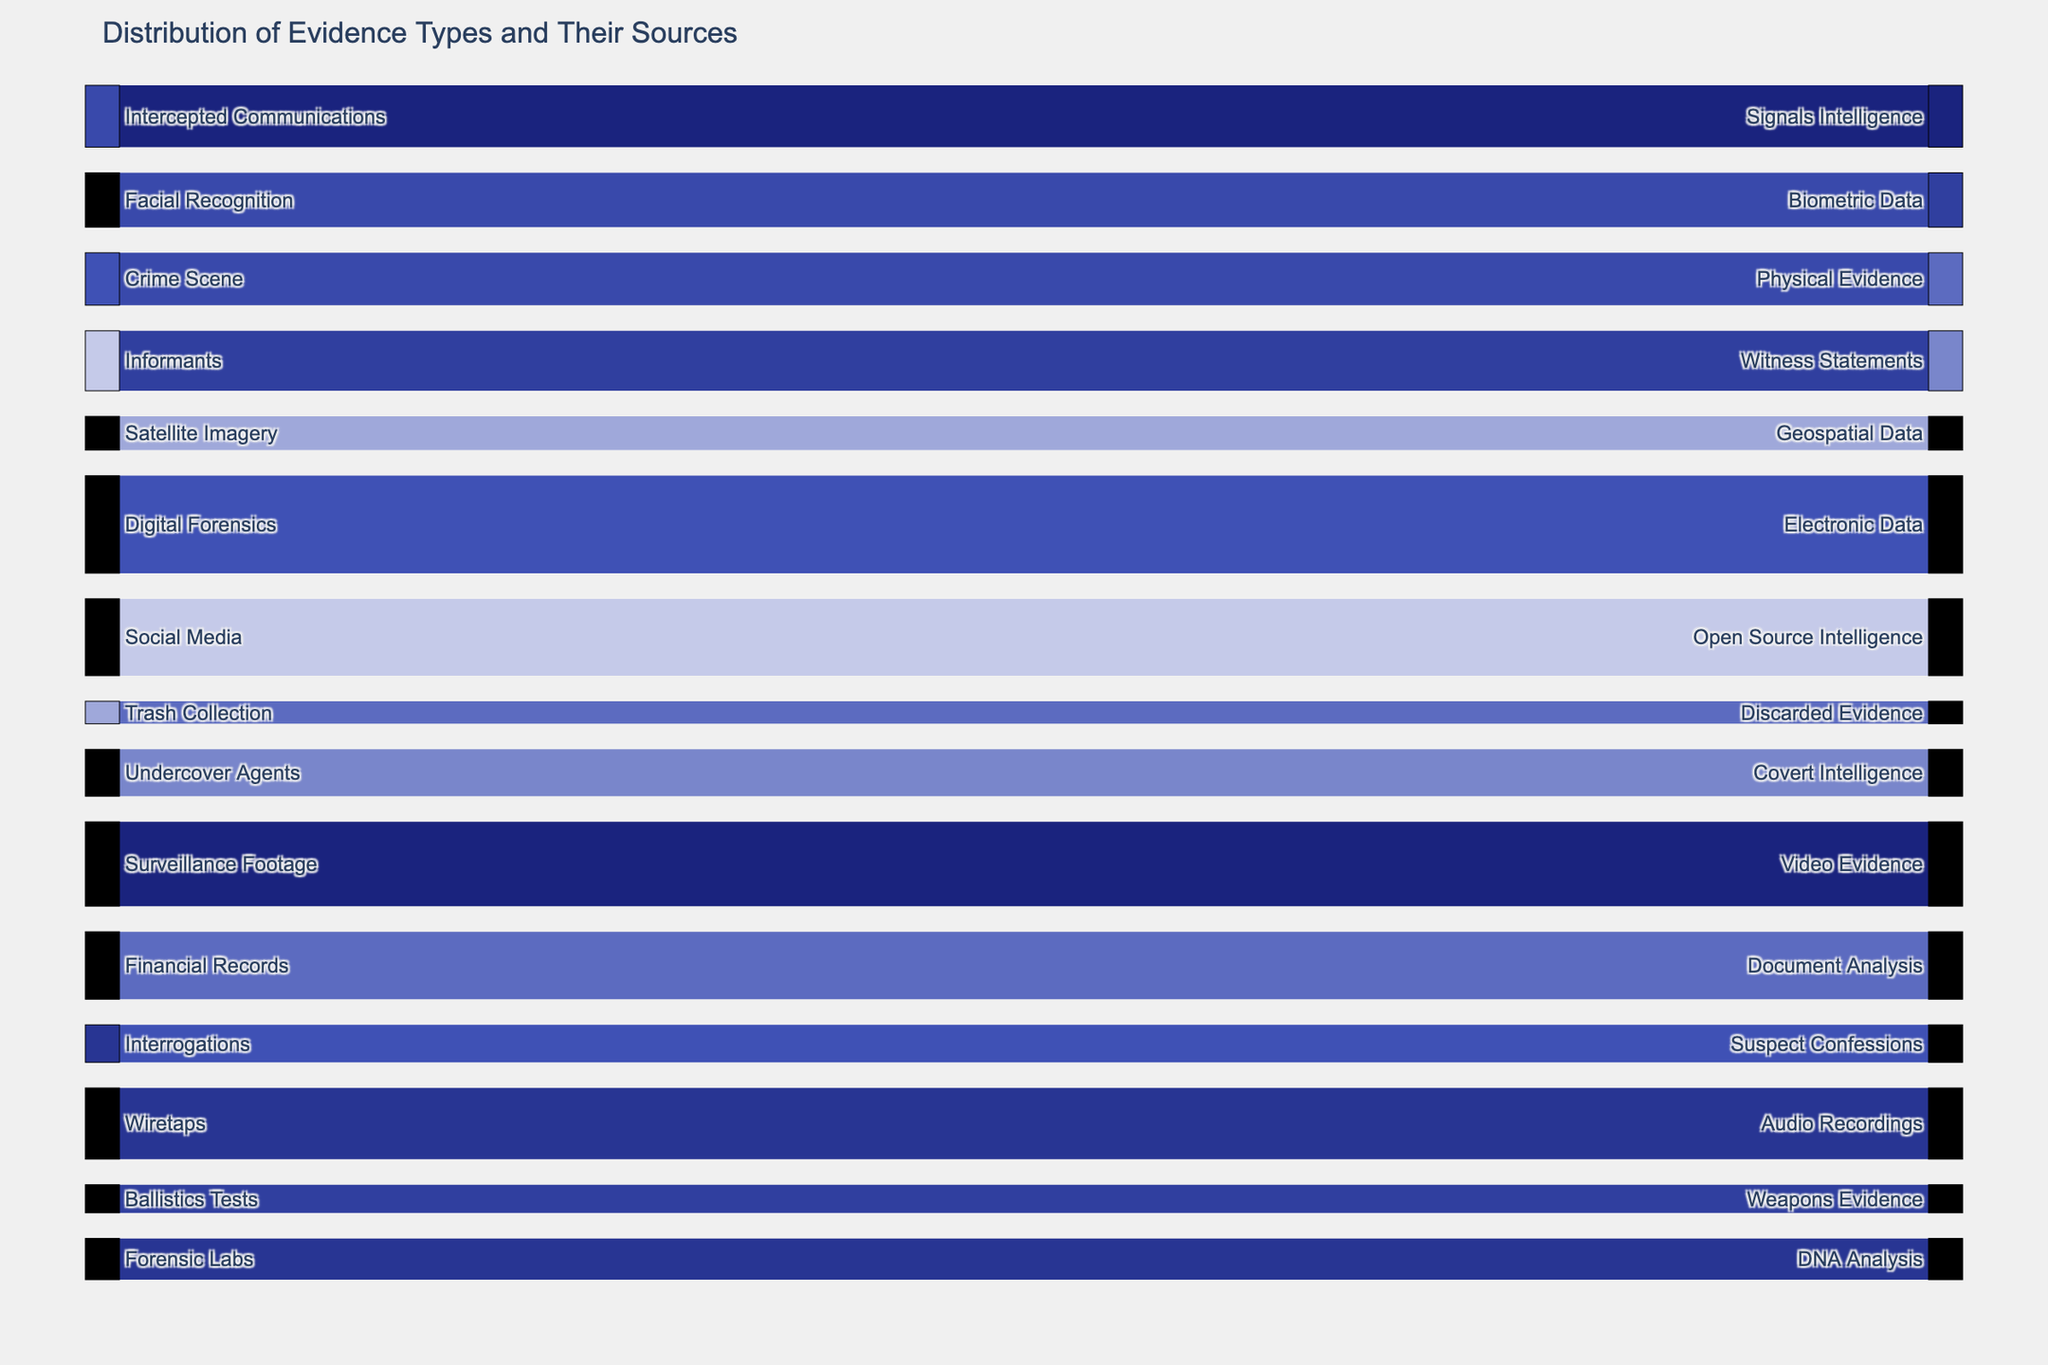What is the predominant type of evidence collected from Digital Forensics? By examining the link from the node "Digital Forensics," it connects to "Electronic Data" with the highest value of 52 among the data points.
Answer: Electronic Data Which source provides the most number of evidence types in the diagram? By counting the links from each source node, "Digital Forensics" provides one type of evidence with a value of 52, which is the highest among all sources.
Answer: Digital Forensics What is the total quantity of evidence types collected from Informants and Interrogations combined? Adding the quantities from "Informants" (32) and "Interrogations" (20) gives us 32 + 20 = 52.
Answer: 52 Which source provides more evidence: Satellite Imagery or Crime Scene? "Satellite Imagery" provides 18, while "Crime Scene" provides 28. Comparing these values shows that "Crime Scene" provides more evidence.
Answer: Crime Scene What are the sources that lead to Biometric Data? Tracing the node "Biometric Data" back to its corresponding source reveals only one link from "Facial Recognition" with 29 units.
Answer: Facial Recognition How much more Physical Evidence is collected compared to Weapons Evidence? Looking at "Physical Evidence" (28) and "Weapons Evidence" (15), the difference is 28 - 15 = 13.
Answer: 13 Which evidence type has the least quantity and what is its source? "Discarded Evidence" has the least quantity with a value of 12, collected from "Trash Collection."
Answer: Discarded Evidence, Trash Collection Among the evidence sources, which one provided the highest quantity of evidence? "Digital Forensics" has the highest quantity of 52 units of evidence.
Answer: Digital Forensics What is the combined total quantity for Audio Recordings and Suspect Confessions? Adding quantities from "Audio Recordings" (38) and "Suspect Confessions" (20), the total is 38 + 20 = 58.
Answer: 58 